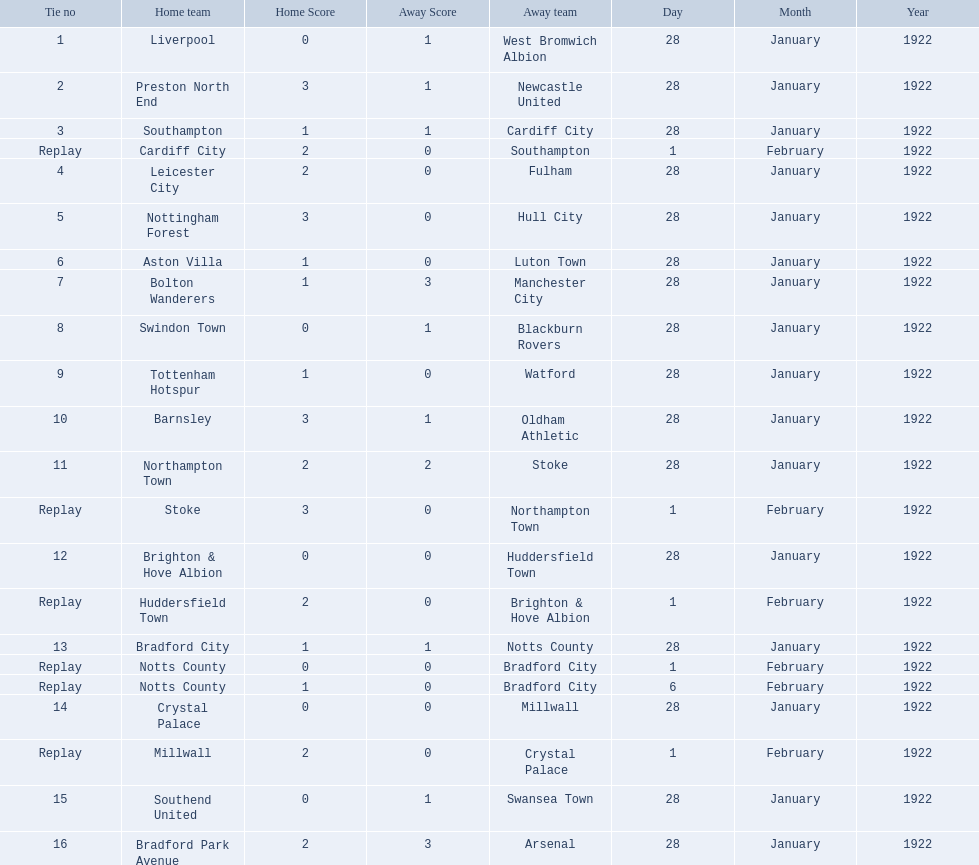Which team had a score of 0-1? Liverpool. Which team had a replay? Cardiff City. Which team had the same score as aston villa? Tottenham Hotspur. 